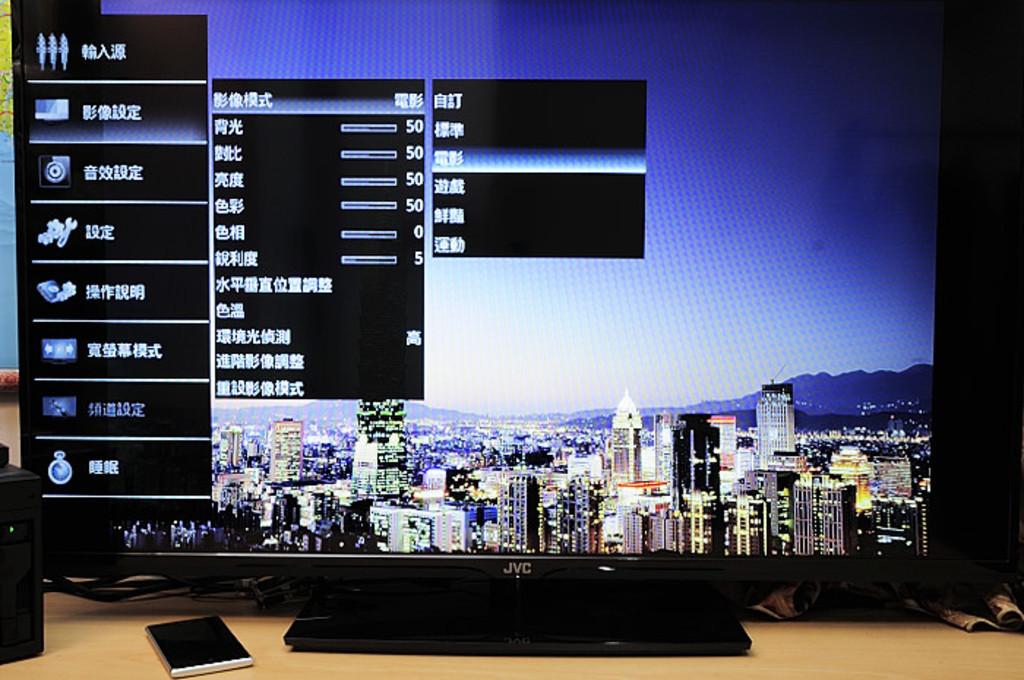What brand is this monitor?
Make the answer very short. Jvc. Is the text in the windows english?
Ensure brevity in your answer.  No. 